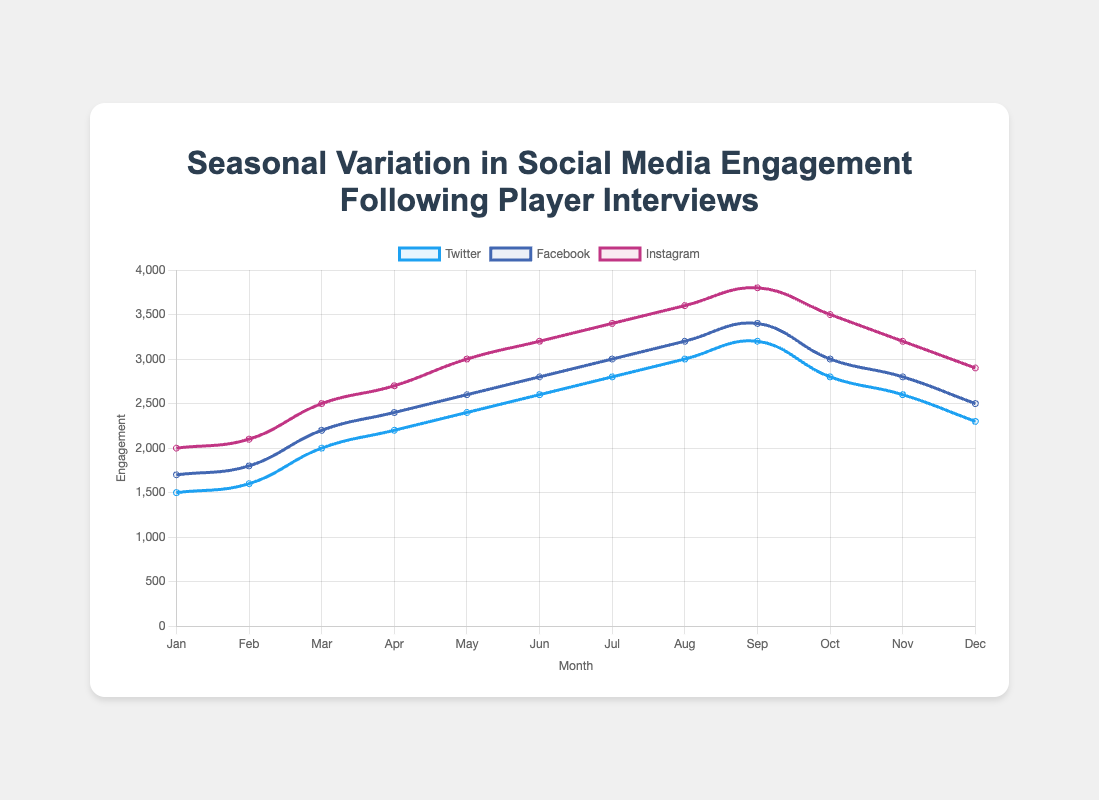Which social media platform had the highest engagement in March? By examining the line plot for the month of March, you can see that Instagram had the highest engagement with a value of 2500.
Answer: Instagram What's the difference in Twitter engagements between April and May? Look at the values for Twitter engagements in April (2200) and May (2400). The difference is 2400 - 2200 = 200.
Answer: 200 How many months did Facebook engagement exceed 3000? The line plot shows that Facebook engagements exceed 3000 in August (3200) and September (3400). These are only 2 months.
Answer: 2 months Which month had the most significant drop in Instagram engagements compared to the previous month? Comparing month-by-month changes, the most significant drop in Instagram engagements occurred from September (3800) to October (3500), a drop of 300.
Answer: October What is the average Twitter engagement for the first half of the year (January to June)? Sum the Twitter engagements from January to June: 1500 + 1600 + 2000 + 2200 + 2400 + 2600 = 12300. The average is 12300 / 6 = 2050.
Answer: 2050 Which month saw Facebook engagements peak? By examining the line plot, you can see that Facebook engagements peaked in September with a value of 3400.
Answer: September How do October's Instagram engagements compare to July's? In October, Instagram engagements were 3500, and in July, they were 3400. October's value is greater by 100.
Answer: October is greater by 100 What's the total social media engagements (sum of Twitter, Facebook, and Instagram) for March? For March, Twitter has 2000, Facebook has 2200, and Instagram has 2500. Total = 2000 + 2200 + 2500 = 6700.
Answer: 6700 Compare the trend of engagements on Instagram and Twitter throughout the year. Both Instagram and Twitter generally increase month by month but peak in September. After September, there is a decline in engagements on both platforms through December.
Answer: Both increase, peak in September, then decline What is the ratio of Facebook to Instagram engagements in December? In December, Facebook has 2500 engagements, and Instagram has 2900. The ratio is 2500:2900, which simplifies to approximately 5:6.
Answer: 5:6 